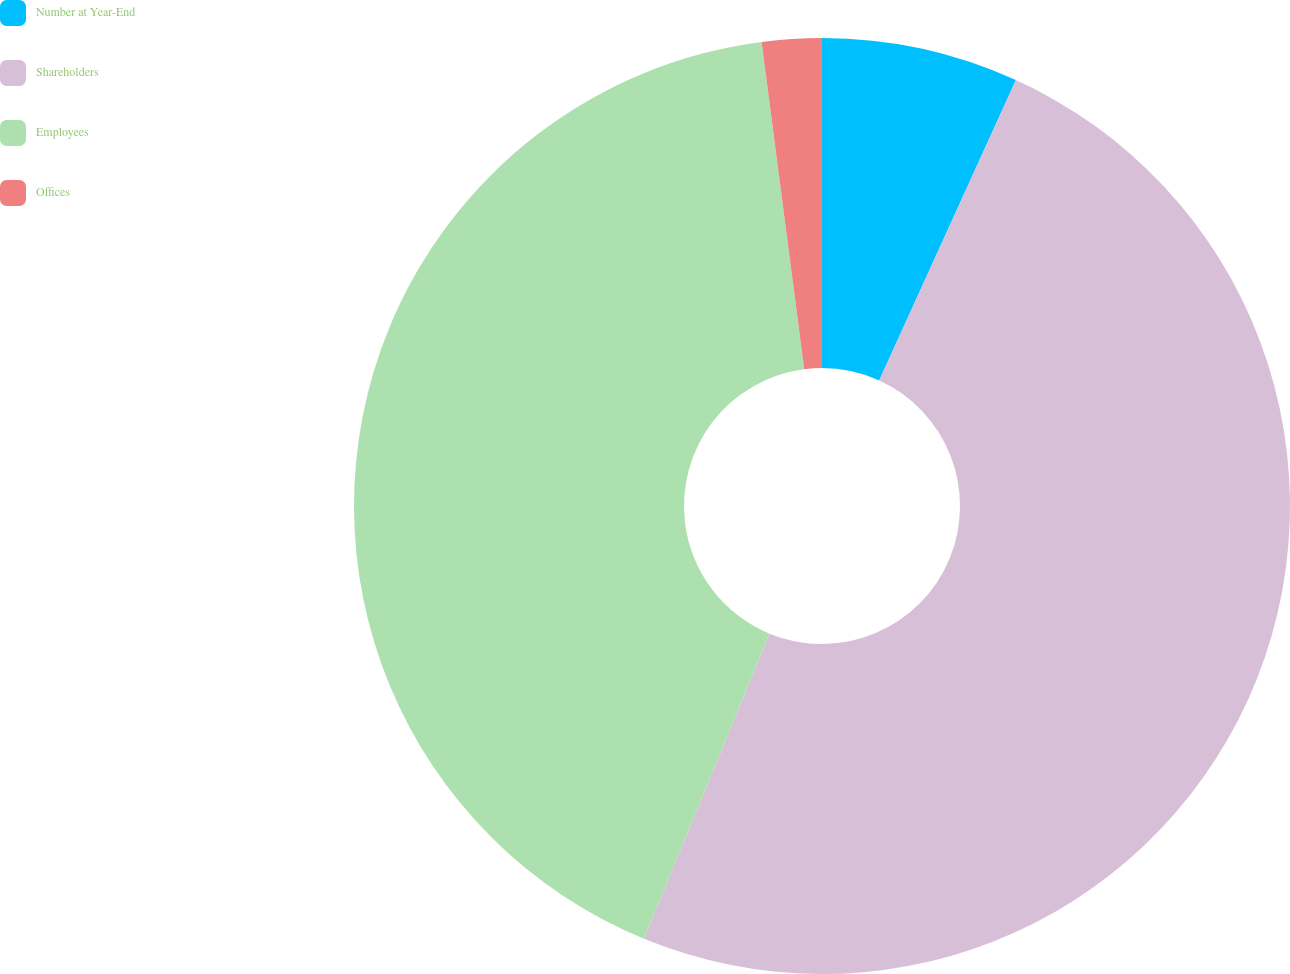<chart> <loc_0><loc_0><loc_500><loc_500><pie_chart><fcel>Number at Year-End<fcel>Shareholders<fcel>Employees<fcel>Offices<nl><fcel>6.8%<fcel>49.41%<fcel>41.73%<fcel>2.06%<nl></chart> 